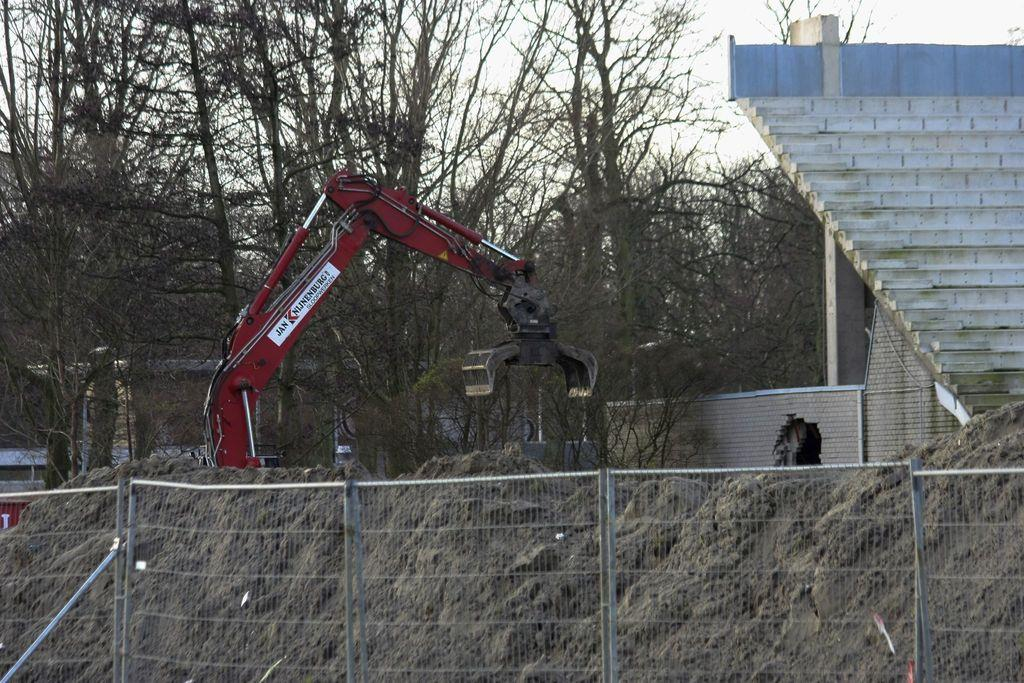What type of structure can be seen in the image? There is a fencing in the image. What is located on the left side of the image? There is a crane on the left side of the image. What architectural feature is present on the right side of the image? There are stairs on the right side of the image. What can be seen in the background of the image? There are trees in the background of the image. What is visible at the top of the image? The sky is visible at the top of the image. Can you tell me how many dinosaurs are visible in the image? There are no dinosaurs present in the image. What type of cat can be seen climbing the stairs in the image? There is no cat present in the image, and therefore no such activity can be observed. 